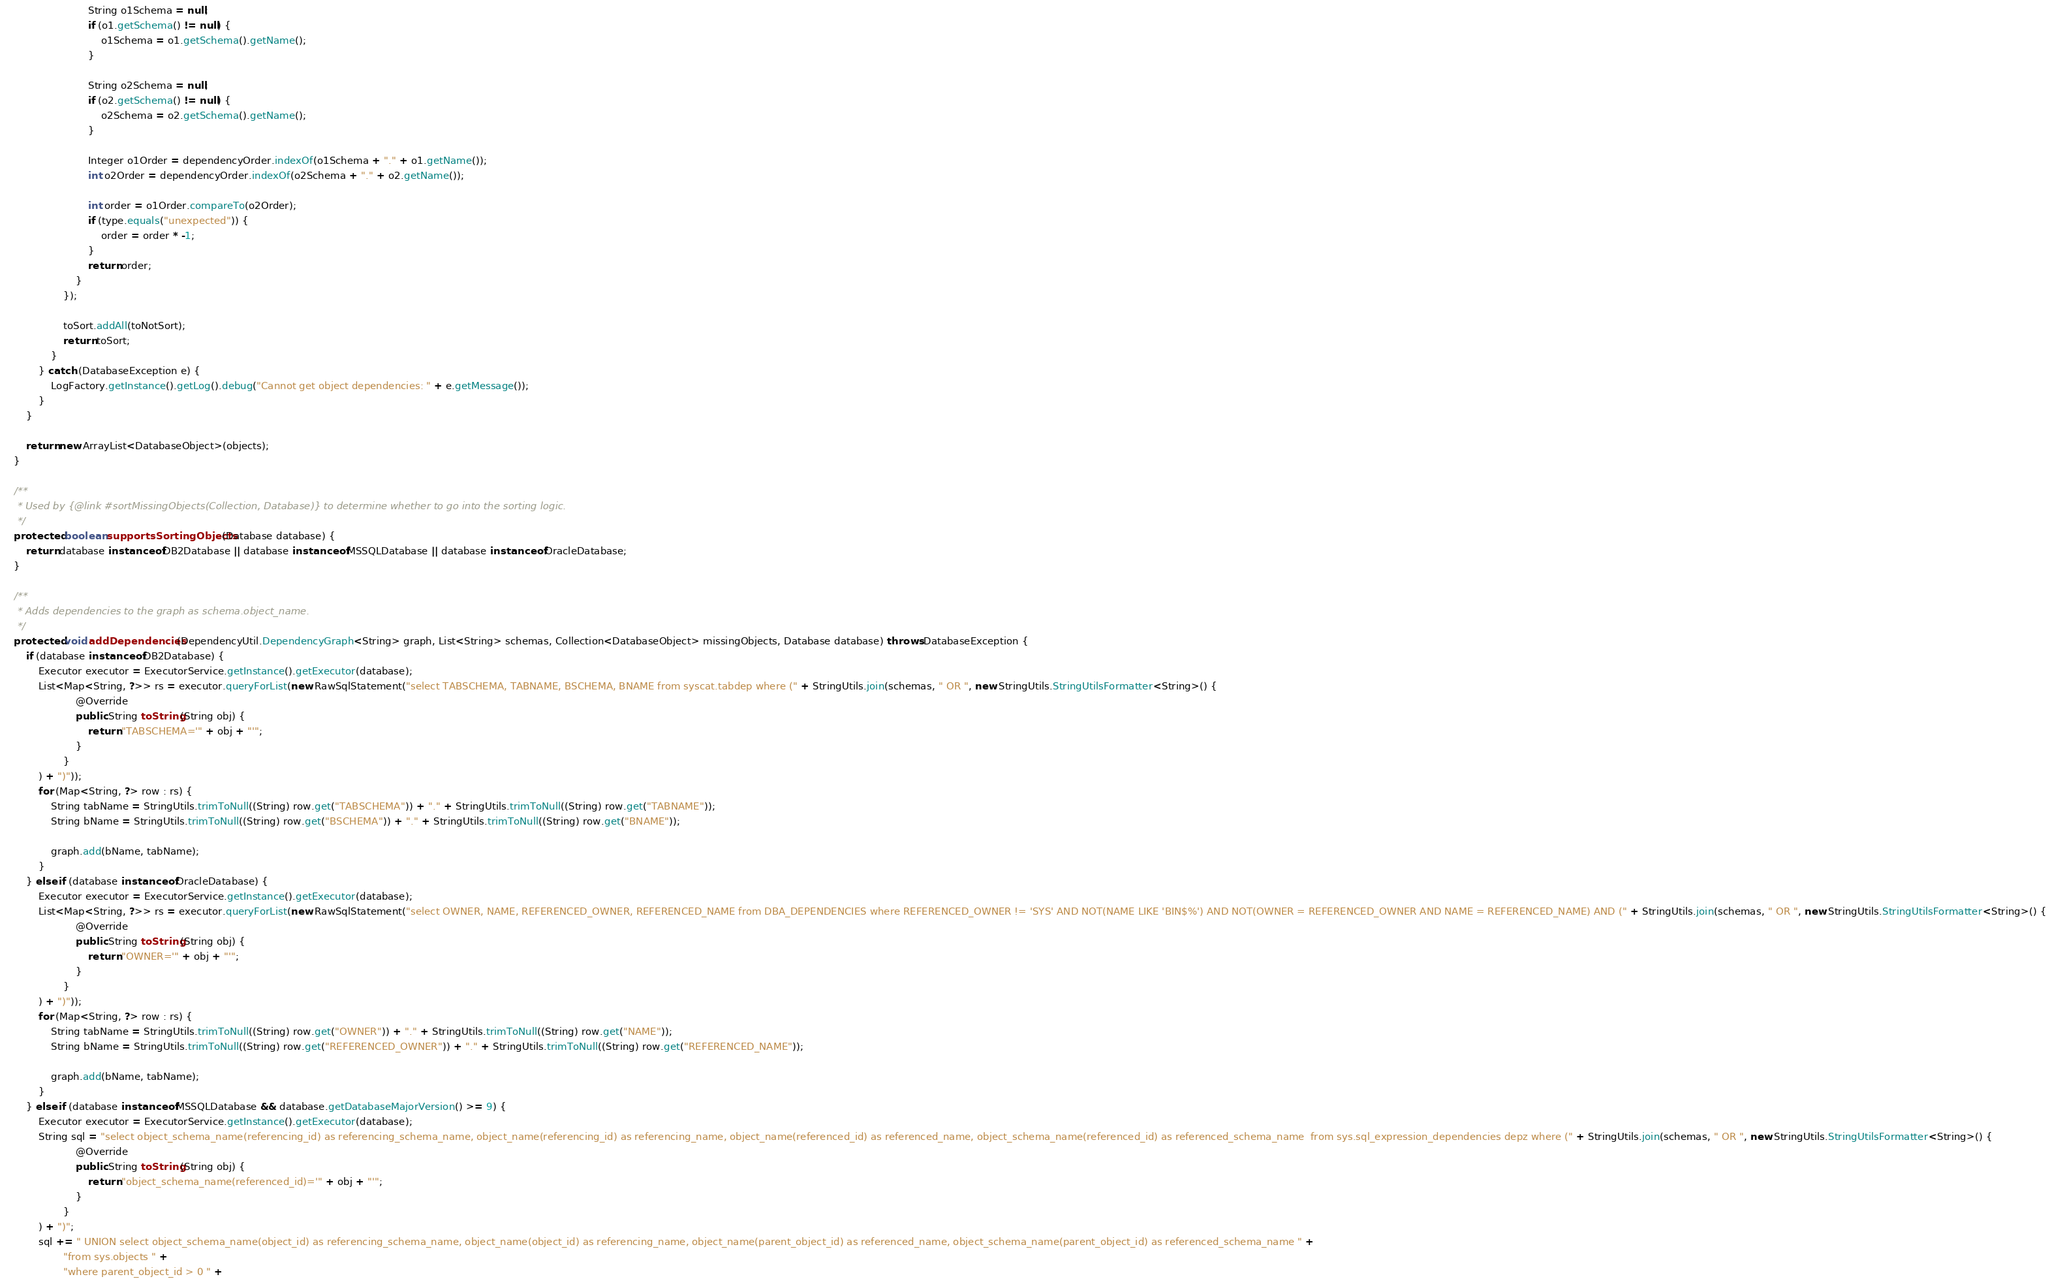Convert code to text. <code><loc_0><loc_0><loc_500><loc_500><_Java_>                            String o1Schema = null;
                            if (o1.getSchema() != null) {
                                o1Schema = o1.getSchema().getName();
                            }

                            String o2Schema = null;
                            if (o2.getSchema() != null) {
                                o2Schema = o2.getSchema().getName();
                            }

                            Integer o1Order = dependencyOrder.indexOf(o1Schema + "." + o1.getName());
                            int o2Order = dependencyOrder.indexOf(o2Schema + "." + o2.getName());

                            int order = o1Order.compareTo(o2Order);
                            if (type.equals("unexpected")) {
                                order = order * -1;
                            }
                            return order;
                        }
                    });

                    toSort.addAll(toNotSort);
                    return toSort;
                }
            } catch (DatabaseException e) {
                LogFactory.getInstance().getLog().debug("Cannot get object dependencies: " + e.getMessage());
            }
        }

        return new ArrayList<DatabaseObject>(objects);
    }

    /**
     * Used by {@link #sortMissingObjects(Collection, Database)} to determine whether to go into the sorting logic.
     */
    protected boolean supportsSortingObjects(Database database) {
        return database instanceof DB2Database || database instanceof MSSQLDatabase || database instanceof OracleDatabase;
    }

    /**
     * Adds dependencies to the graph as schema.object_name.
     */
    protected void addDependencies(DependencyUtil.DependencyGraph<String> graph, List<String> schemas, Collection<DatabaseObject> missingObjects, Database database) throws DatabaseException {
        if (database instanceof DB2Database) {
            Executor executor = ExecutorService.getInstance().getExecutor(database);
            List<Map<String, ?>> rs = executor.queryForList(new RawSqlStatement("select TABSCHEMA, TABNAME, BSCHEMA, BNAME from syscat.tabdep where (" + StringUtils.join(schemas, " OR ", new StringUtils.StringUtilsFormatter<String>() {
                        @Override
                        public String toString(String obj) {
                            return "TABSCHEMA='" + obj + "'";
                        }
                    }
            ) + ")"));
            for (Map<String, ?> row : rs) {
                String tabName = StringUtils.trimToNull((String) row.get("TABSCHEMA")) + "." + StringUtils.trimToNull((String) row.get("TABNAME"));
                String bName = StringUtils.trimToNull((String) row.get("BSCHEMA")) + "." + StringUtils.trimToNull((String) row.get("BNAME"));

                graph.add(bName, tabName);
            }
        } else if (database instanceof OracleDatabase) {
            Executor executor = ExecutorService.getInstance().getExecutor(database);
            List<Map<String, ?>> rs = executor.queryForList(new RawSqlStatement("select OWNER, NAME, REFERENCED_OWNER, REFERENCED_NAME from DBA_DEPENDENCIES where REFERENCED_OWNER != 'SYS' AND NOT(NAME LIKE 'BIN$%') AND NOT(OWNER = REFERENCED_OWNER AND NAME = REFERENCED_NAME) AND (" + StringUtils.join(schemas, " OR ", new StringUtils.StringUtilsFormatter<String>() {
                        @Override
                        public String toString(String obj) {
                            return "OWNER='" + obj + "'";
                        }
                    }
            ) + ")"));
            for (Map<String, ?> row : rs) {
                String tabName = StringUtils.trimToNull((String) row.get("OWNER")) + "." + StringUtils.trimToNull((String) row.get("NAME"));
                String bName = StringUtils.trimToNull((String) row.get("REFERENCED_OWNER")) + "." + StringUtils.trimToNull((String) row.get("REFERENCED_NAME"));

                graph.add(bName, tabName);
            }
        } else if (database instanceof MSSQLDatabase && database.getDatabaseMajorVersion() >= 9) {
            Executor executor = ExecutorService.getInstance().getExecutor(database);
            String sql = "select object_schema_name(referencing_id) as referencing_schema_name, object_name(referencing_id) as referencing_name, object_name(referenced_id) as referenced_name, object_schema_name(referenced_id) as referenced_schema_name  from sys.sql_expression_dependencies depz where (" + StringUtils.join(schemas, " OR ", new StringUtils.StringUtilsFormatter<String>() {
                        @Override
                        public String toString(String obj) {
                            return "object_schema_name(referenced_id)='" + obj + "'";
                        }
                    }
            ) + ")";
            sql += " UNION select object_schema_name(object_id) as referencing_schema_name, object_name(object_id) as referencing_name, object_name(parent_object_id) as referenced_name, object_schema_name(parent_object_id) as referenced_schema_name " +
                    "from sys.objects " +
                    "where parent_object_id > 0 " +</code> 